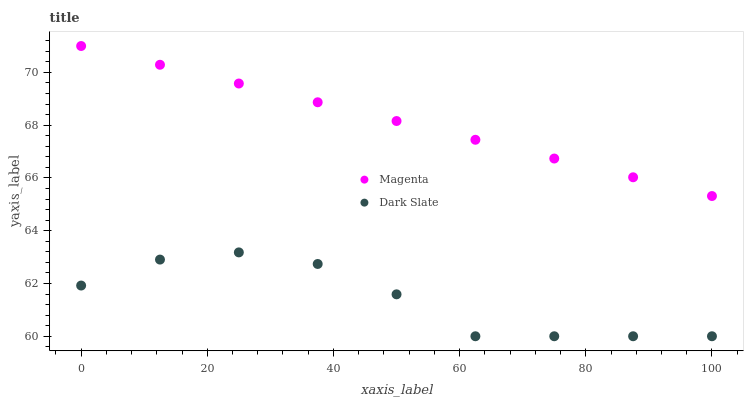Does Dark Slate have the minimum area under the curve?
Answer yes or no. Yes. Does Magenta have the maximum area under the curve?
Answer yes or no. Yes. Does Magenta have the minimum area under the curve?
Answer yes or no. No. Is Magenta the smoothest?
Answer yes or no. Yes. Is Dark Slate the roughest?
Answer yes or no. Yes. Is Magenta the roughest?
Answer yes or no. No. Does Dark Slate have the lowest value?
Answer yes or no. Yes. Does Magenta have the lowest value?
Answer yes or no. No. Does Magenta have the highest value?
Answer yes or no. Yes. Is Dark Slate less than Magenta?
Answer yes or no. Yes. Is Magenta greater than Dark Slate?
Answer yes or no. Yes. Does Dark Slate intersect Magenta?
Answer yes or no. No. 